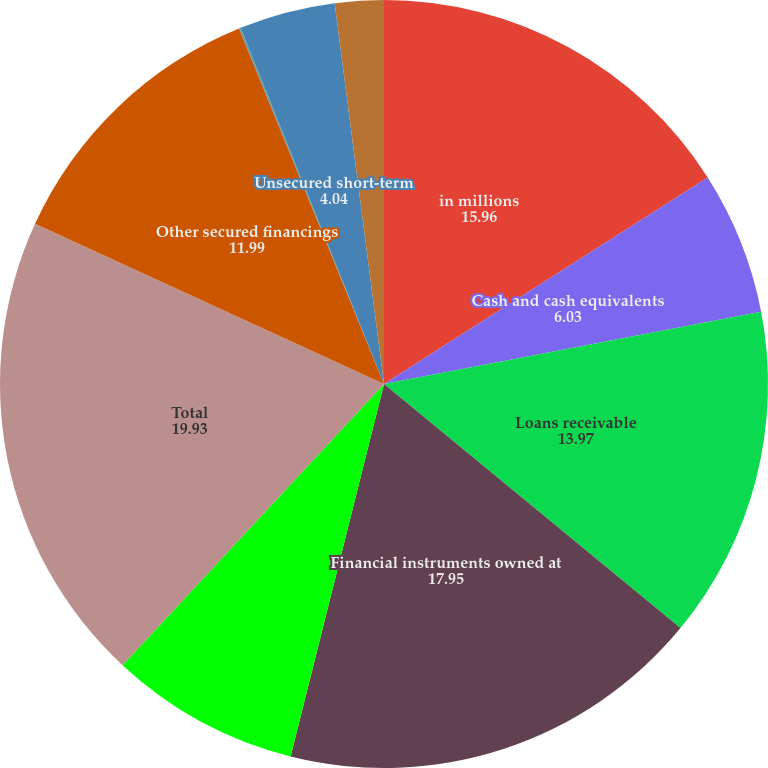Convert chart. <chart><loc_0><loc_0><loc_500><loc_500><pie_chart><fcel>in millions<fcel>Cash and cash equivalents<fcel>Loans receivable<fcel>Financial instruments owned at<fcel>Other assets<fcel>Total<fcel>Other secured financings<fcel>Financial instruments sold but<fcel>Unsecured short-term<fcel>Unsecured long-term borrowings<nl><fcel>15.96%<fcel>6.03%<fcel>13.97%<fcel>17.95%<fcel>8.01%<fcel>19.93%<fcel>11.99%<fcel>0.07%<fcel>4.04%<fcel>2.05%<nl></chart> 